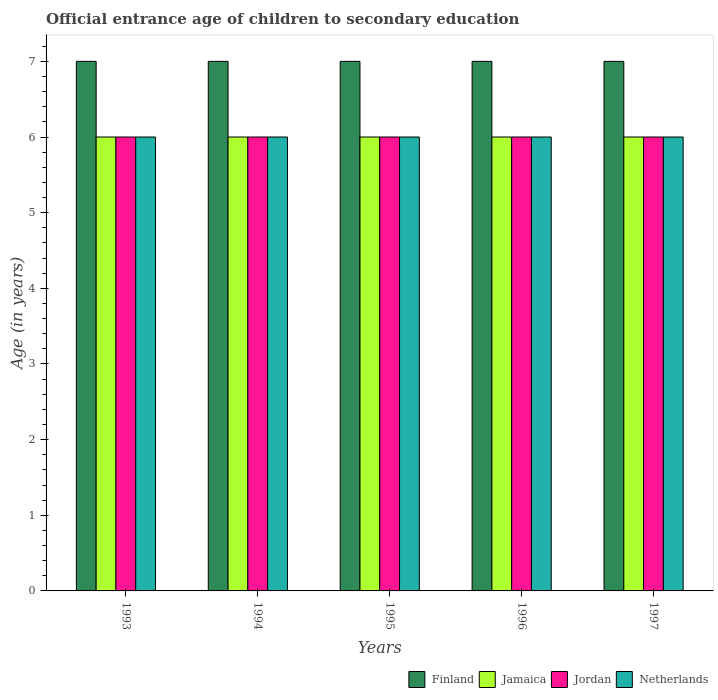Are the number of bars on each tick of the X-axis equal?
Your answer should be very brief. Yes. How many bars are there on the 2nd tick from the right?
Provide a succinct answer. 4. What is the label of the 3rd group of bars from the left?
Offer a very short reply. 1995. What is the secondary school starting age of children in Finland in 1997?
Your response must be concise. 7. Across all years, what is the maximum secondary school starting age of children in Jamaica?
Provide a short and direct response. 6. Across all years, what is the minimum secondary school starting age of children in Netherlands?
Provide a short and direct response. 6. In which year was the secondary school starting age of children in Netherlands minimum?
Your answer should be compact. 1993. What is the total secondary school starting age of children in Finland in the graph?
Offer a very short reply. 35. What is the difference between the secondary school starting age of children in Jamaica in 1993 and the secondary school starting age of children in Finland in 1995?
Offer a very short reply. -1. What is the average secondary school starting age of children in Netherlands per year?
Give a very brief answer. 6. In the year 1993, what is the difference between the secondary school starting age of children in Jamaica and secondary school starting age of children in Netherlands?
Provide a short and direct response. 0. In how many years, is the secondary school starting age of children in Netherlands greater than 7 years?
Offer a very short reply. 0. What is the difference between the highest and the second highest secondary school starting age of children in Finland?
Offer a terse response. 0. What is the difference between the highest and the lowest secondary school starting age of children in Jamaica?
Offer a terse response. 0. In how many years, is the secondary school starting age of children in Netherlands greater than the average secondary school starting age of children in Netherlands taken over all years?
Provide a short and direct response. 0. What does the 2nd bar from the left in 1997 represents?
Ensure brevity in your answer.  Jamaica. Is it the case that in every year, the sum of the secondary school starting age of children in Finland and secondary school starting age of children in Jamaica is greater than the secondary school starting age of children in Jordan?
Your answer should be very brief. Yes. Are all the bars in the graph horizontal?
Provide a short and direct response. No. How many years are there in the graph?
Your response must be concise. 5. What is the difference between two consecutive major ticks on the Y-axis?
Ensure brevity in your answer.  1. Does the graph contain any zero values?
Ensure brevity in your answer.  No. How are the legend labels stacked?
Give a very brief answer. Horizontal. What is the title of the graph?
Your answer should be very brief. Official entrance age of children to secondary education. What is the label or title of the Y-axis?
Ensure brevity in your answer.  Age (in years). What is the Age (in years) of Jordan in 1993?
Give a very brief answer. 6. What is the Age (in years) of Finland in 1994?
Give a very brief answer. 7. What is the Age (in years) of Jamaica in 1994?
Provide a short and direct response. 6. What is the Age (in years) in Jordan in 1994?
Provide a succinct answer. 6. What is the Age (in years) of Jamaica in 1995?
Give a very brief answer. 6. What is the Age (in years) of Finland in 1996?
Your answer should be compact. 7. What is the Age (in years) in Jamaica in 1996?
Provide a succinct answer. 6. What is the Age (in years) of Jordan in 1996?
Provide a short and direct response. 6. What is the Age (in years) in Netherlands in 1996?
Provide a short and direct response. 6. What is the Age (in years) in Finland in 1997?
Make the answer very short. 7. What is the Age (in years) of Jamaica in 1997?
Provide a succinct answer. 6. What is the Age (in years) in Jordan in 1997?
Keep it short and to the point. 6. What is the Age (in years) in Netherlands in 1997?
Your answer should be very brief. 6. Across all years, what is the maximum Age (in years) of Jordan?
Keep it short and to the point. 6. Across all years, what is the minimum Age (in years) of Netherlands?
Give a very brief answer. 6. What is the total Age (in years) of Jordan in the graph?
Provide a succinct answer. 30. What is the difference between the Age (in years) in Jamaica in 1993 and that in 1994?
Keep it short and to the point. 0. What is the difference between the Age (in years) in Finland in 1993 and that in 1995?
Ensure brevity in your answer.  0. What is the difference between the Age (in years) in Jordan in 1993 and that in 1995?
Offer a terse response. 0. What is the difference between the Age (in years) in Netherlands in 1993 and that in 1995?
Your response must be concise. 0. What is the difference between the Age (in years) in Jordan in 1993 and that in 1996?
Provide a succinct answer. 0. What is the difference between the Age (in years) of Jordan in 1993 and that in 1997?
Offer a terse response. 0. What is the difference between the Age (in years) in Netherlands in 1993 and that in 1997?
Your response must be concise. 0. What is the difference between the Age (in years) of Finland in 1994 and that in 1995?
Your answer should be very brief. 0. What is the difference between the Age (in years) in Jamaica in 1994 and that in 1995?
Make the answer very short. 0. What is the difference between the Age (in years) in Jamaica in 1994 and that in 1996?
Provide a short and direct response. 0. What is the difference between the Age (in years) in Netherlands in 1995 and that in 1996?
Provide a short and direct response. 0. What is the difference between the Age (in years) of Jamaica in 1995 and that in 1997?
Ensure brevity in your answer.  0. What is the difference between the Age (in years) of Jordan in 1995 and that in 1997?
Your response must be concise. 0. What is the difference between the Age (in years) in Netherlands in 1995 and that in 1997?
Offer a very short reply. 0. What is the difference between the Age (in years) in Netherlands in 1996 and that in 1997?
Give a very brief answer. 0. What is the difference between the Age (in years) of Jamaica in 1993 and the Age (in years) of Jordan in 1994?
Provide a short and direct response. 0. What is the difference between the Age (in years) in Jamaica in 1993 and the Age (in years) in Netherlands in 1994?
Your response must be concise. 0. What is the difference between the Age (in years) in Jordan in 1993 and the Age (in years) in Netherlands in 1994?
Keep it short and to the point. 0. What is the difference between the Age (in years) in Finland in 1993 and the Age (in years) in Jamaica in 1995?
Keep it short and to the point. 1. What is the difference between the Age (in years) of Jordan in 1993 and the Age (in years) of Netherlands in 1995?
Your response must be concise. 0. What is the difference between the Age (in years) of Finland in 1993 and the Age (in years) of Jamaica in 1996?
Ensure brevity in your answer.  1. What is the difference between the Age (in years) of Finland in 1993 and the Age (in years) of Netherlands in 1996?
Your answer should be very brief. 1. What is the difference between the Age (in years) of Jamaica in 1993 and the Age (in years) of Jordan in 1996?
Ensure brevity in your answer.  0. What is the difference between the Age (in years) in Jamaica in 1993 and the Age (in years) in Netherlands in 1996?
Keep it short and to the point. 0. What is the difference between the Age (in years) in Finland in 1993 and the Age (in years) in Jordan in 1997?
Provide a short and direct response. 1. What is the difference between the Age (in years) in Finland in 1993 and the Age (in years) in Netherlands in 1997?
Your answer should be very brief. 1. What is the difference between the Age (in years) in Jamaica in 1993 and the Age (in years) in Jordan in 1997?
Keep it short and to the point. 0. What is the difference between the Age (in years) in Jordan in 1993 and the Age (in years) in Netherlands in 1997?
Your response must be concise. 0. What is the difference between the Age (in years) in Finland in 1994 and the Age (in years) in Jordan in 1995?
Your answer should be compact. 1. What is the difference between the Age (in years) in Jamaica in 1994 and the Age (in years) in Jordan in 1995?
Ensure brevity in your answer.  0. What is the difference between the Age (in years) in Jamaica in 1994 and the Age (in years) in Netherlands in 1995?
Provide a short and direct response. 0. What is the difference between the Age (in years) of Finland in 1994 and the Age (in years) of Jamaica in 1996?
Make the answer very short. 1. What is the difference between the Age (in years) in Finland in 1994 and the Age (in years) in Jordan in 1996?
Offer a terse response. 1. What is the difference between the Age (in years) in Jamaica in 1994 and the Age (in years) in Jordan in 1996?
Make the answer very short. 0. What is the difference between the Age (in years) in Jordan in 1994 and the Age (in years) in Netherlands in 1996?
Your response must be concise. 0. What is the difference between the Age (in years) of Finland in 1994 and the Age (in years) of Jamaica in 1997?
Provide a succinct answer. 1. What is the difference between the Age (in years) of Finland in 1994 and the Age (in years) of Netherlands in 1997?
Provide a short and direct response. 1. What is the difference between the Age (in years) in Jordan in 1995 and the Age (in years) in Netherlands in 1996?
Make the answer very short. 0. What is the difference between the Age (in years) of Finland in 1995 and the Age (in years) of Jamaica in 1997?
Your answer should be very brief. 1. What is the difference between the Age (in years) of Finland in 1995 and the Age (in years) of Netherlands in 1997?
Make the answer very short. 1. What is the difference between the Age (in years) of Jamaica in 1995 and the Age (in years) of Jordan in 1997?
Ensure brevity in your answer.  0. What is the difference between the Age (in years) of Jordan in 1995 and the Age (in years) of Netherlands in 1997?
Provide a succinct answer. 0. What is the difference between the Age (in years) in Finland in 1996 and the Age (in years) in Jamaica in 1997?
Your answer should be very brief. 1. What is the difference between the Age (in years) of Finland in 1996 and the Age (in years) of Jordan in 1997?
Make the answer very short. 1. What is the difference between the Age (in years) of Jamaica in 1996 and the Age (in years) of Jordan in 1997?
Provide a succinct answer. 0. What is the difference between the Age (in years) of Jamaica in 1996 and the Age (in years) of Netherlands in 1997?
Offer a very short reply. 0. What is the difference between the Age (in years) of Jordan in 1996 and the Age (in years) of Netherlands in 1997?
Provide a succinct answer. 0. In the year 1993, what is the difference between the Age (in years) in Finland and Age (in years) in Jamaica?
Provide a short and direct response. 1. In the year 1993, what is the difference between the Age (in years) of Finland and Age (in years) of Jordan?
Provide a succinct answer. 1. In the year 1993, what is the difference between the Age (in years) in Jordan and Age (in years) in Netherlands?
Ensure brevity in your answer.  0. In the year 1994, what is the difference between the Age (in years) of Finland and Age (in years) of Jordan?
Offer a terse response. 1. In the year 1994, what is the difference between the Age (in years) of Jordan and Age (in years) of Netherlands?
Keep it short and to the point. 0. In the year 1995, what is the difference between the Age (in years) of Finland and Age (in years) of Jordan?
Ensure brevity in your answer.  1. In the year 1995, what is the difference between the Age (in years) in Jamaica and Age (in years) in Netherlands?
Offer a terse response. 0. In the year 1996, what is the difference between the Age (in years) of Finland and Age (in years) of Jordan?
Give a very brief answer. 1. In the year 1996, what is the difference between the Age (in years) in Jamaica and Age (in years) in Jordan?
Offer a very short reply. 0. In the year 1996, what is the difference between the Age (in years) of Jamaica and Age (in years) of Netherlands?
Keep it short and to the point. 0. In the year 1996, what is the difference between the Age (in years) of Jordan and Age (in years) of Netherlands?
Your response must be concise. 0. In the year 1997, what is the difference between the Age (in years) of Finland and Age (in years) of Jamaica?
Provide a short and direct response. 1. In the year 1997, what is the difference between the Age (in years) in Finland and Age (in years) in Netherlands?
Keep it short and to the point. 1. In the year 1997, what is the difference between the Age (in years) of Jamaica and Age (in years) of Jordan?
Make the answer very short. 0. What is the ratio of the Age (in years) of Jamaica in 1993 to that in 1994?
Keep it short and to the point. 1. What is the ratio of the Age (in years) in Netherlands in 1993 to that in 1994?
Give a very brief answer. 1. What is the ratio of the Age (in years) in Finland in 1993 to that in 1995?
Provide a succinct answer. 1. What is the ratio of the Age (in years) in Jamaica in 1993 to that in 1995?
Offer a terse response. 1. What is the ratio of the Age (in years) of Jordan in 1993 to that in 1995?
Offer a very short reply. 1. What is the ratio of the Age (in years) of Jamaica in 1993 to that in 1996?
Your answer should be very brief. 1. What is the ratio of the Age (in years) of Jamaica in 1993 to that in 1997?
Give a very brief answer. 1. What is the ratio of the Age (in years) of Jordan in 1993 to that in 1997?
Give a very brief answer. 1. What is the ratio of the Age (in years) in Jordan in 1994 to that in 1995?
Your response must be concise. 1. What is the ratio of the Age (in years) of Netherlands in 1994 to that in 1995?
Provide a succinct answer. 1. What is the ratio of the Age (in years) of Netherlands in 1994 to that in 1996?
Your answer should be very brief. 1. What is the ratio of the Age (in years) in Finland in 1994 to that in 1997?
Offer a very short reply. 1. What is the ratio of the Age (in years) in Jamaica in 1994 to that in 1997?
Ensure brevity in your answer.  1. What is the ratio of the Age (in years) of Finland in 1995 to that in 1996?
Offer a very short reply. 1. What is the ratio of the Age (in years) in Jordan in 1995 to that in 1996?
Your answer should be very brief. 1. What is the ratio of the Age (in years) in Finland in 1995 to that in 1997?
Offer a terse response. 1. What is the ratio of the Age (in years) in Jordan in 1995 to that in 1997?
Provide a short and direct response. 1. What is the ratio of the Age (in years) in Finland in 1996 to that in 1997?
Your response must be concise. 1. What is the ratio of the Age (in years) in Jordan in 1996 to that in 1997?
Your answer should be very brief. 1. What is the difference between the highest and the second highest Age (in years) of Jordan?
Keep it short and to the point. 0. What is the difference between the highest and the second highest Age (in years) in Netherlands?
Give a very brief answer. 0. What is the difference between the highest and the lowest Age (in years) in Finland?
Offer a very short reply. 0. What is the difference between the highest and the lowest Age (in years) of Jamaica?
Provide a succinct answer. 0. 